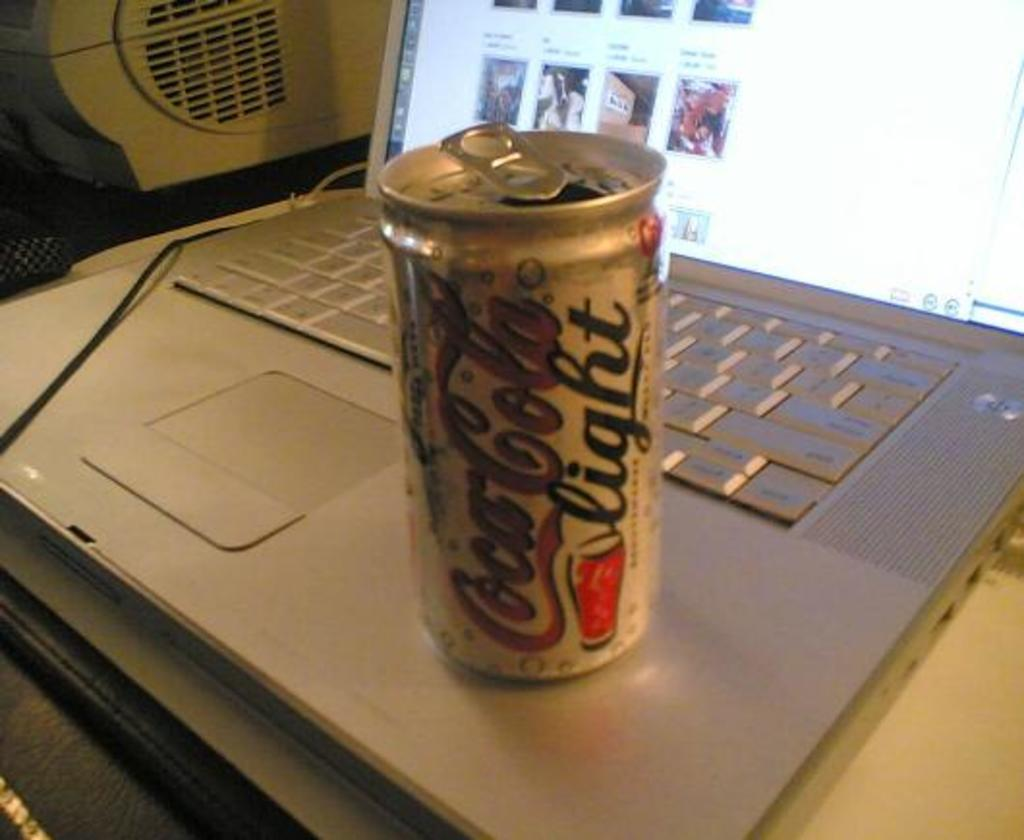<image>
Describe the image concisely. a Coors Light beer that is on a laptop 